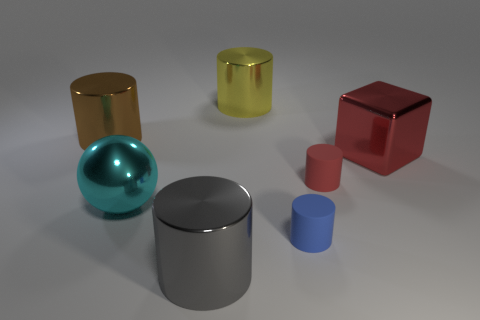What material is the tiny object behind the blue rubber cylinder?
Ensure brevity in your answer.  Rubber. There is a large sphere that is the same material as the gray object; what color is it?
Give a very brief answer. Cyan. How many green matte cubes have the same size as the sphere?
Make the answer very short. 0. There is a cyan shiny object that is behind the gray thing; does it have the same size as the red rubber cylinder?
Offer a very short reply. No. There is a object that is on the left side of the big gray cylinder and in front of the red matte thing; what is its shape?
Offer a very short reply. Sphere. Are there any big red shiny cubes in front of the red metal thing?
Ensure brevity in your answer.  No. Are there any other things that are the same shape as the cyan metallic thing?
Offer a very short reply. No. Do the brown metallic thing and the large cyan metal thing have the same shape?
Your response must be concise. No. Is the number of big gray cylinders that are behind the big cyan metal sphere the same as the number of big yellow metal objects that are on the right side of the yellow thing?
Your answer should be compact. Yes. What number of other objects are the same material as the cyan ball?
Make the answer very short. 4. 